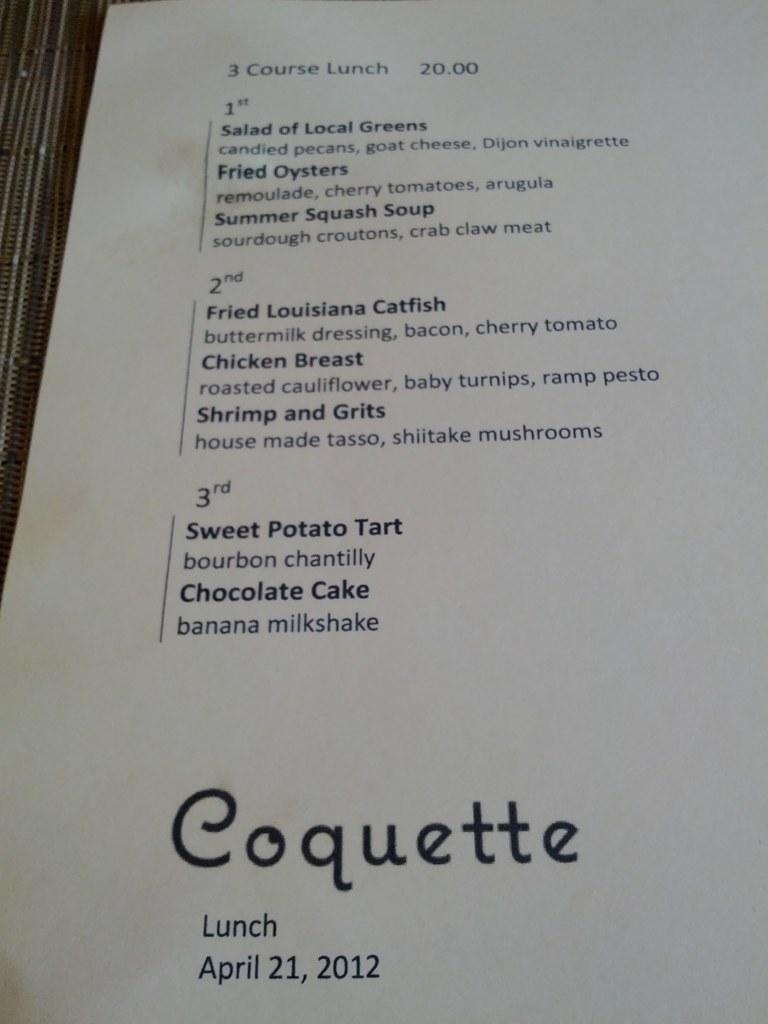<image>
Describe the image concisely. Three-course lunch menu for Coquette restaurant from April 2012. 